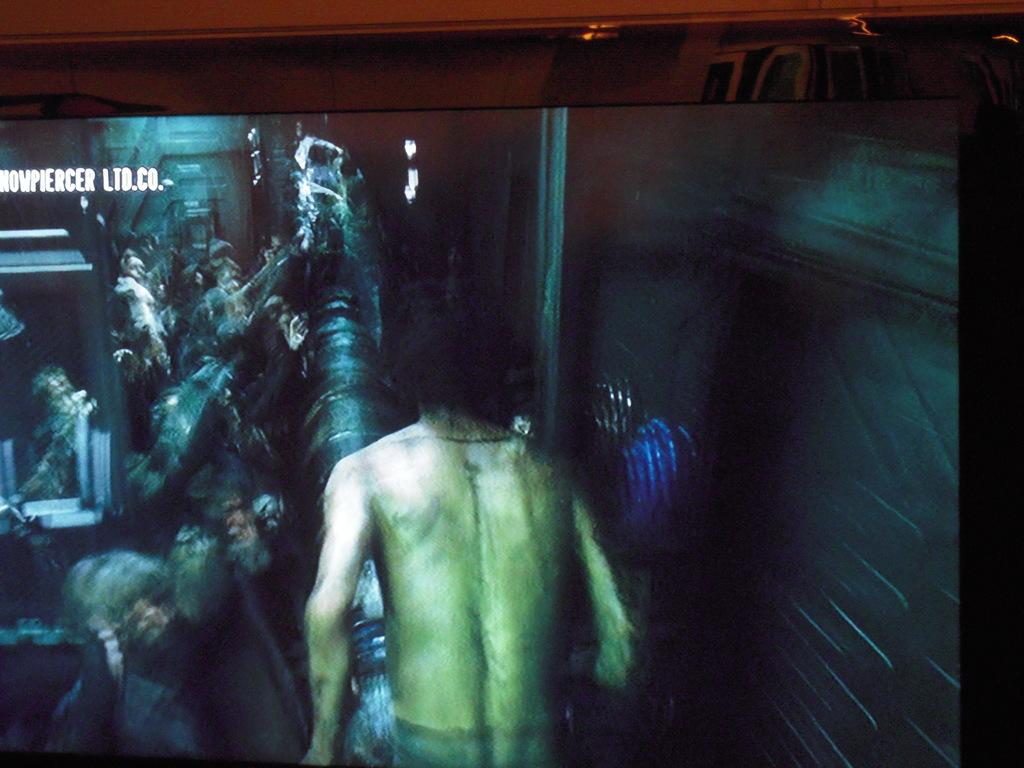Who or what is the main subject in the front of the image? There is a person in the front of the image. What can be observed about the background of the image? The background of the image is blurry. Is there any text visible in the image? Yes, there is text written in the background of the image. How many gloves can be seen in the image? There are no gloves present in the image. What fact about zebras can be learned from the image? The image does not contain any information about zebras, so no fact can be learned from it. 